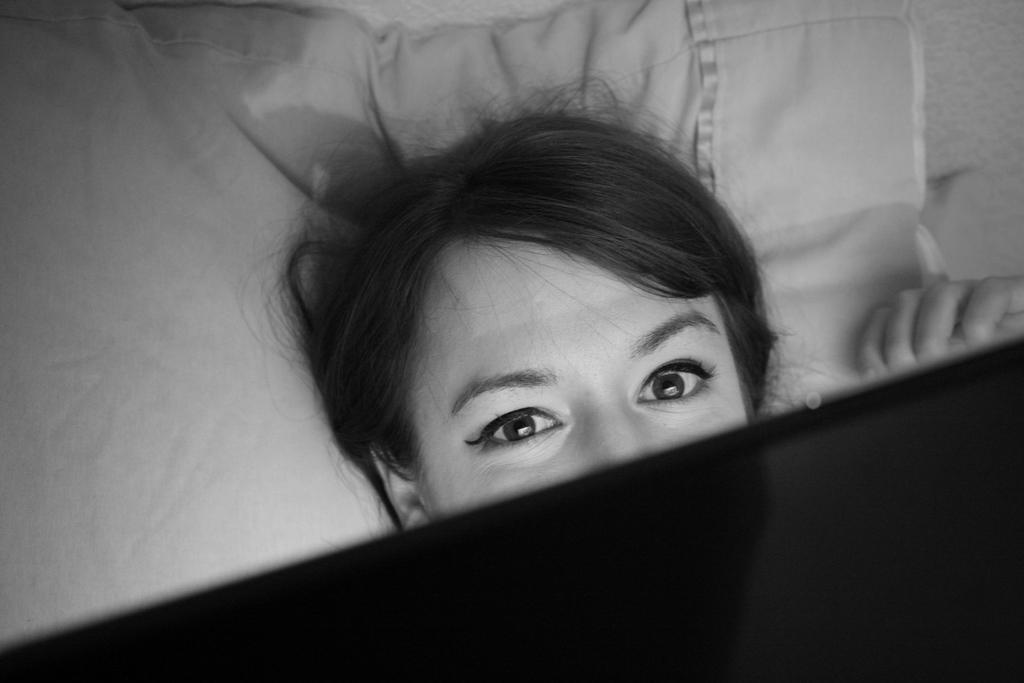Who is present in the image? There is a woman in the image. What part of the woman's face is visible? The woman's eyes are visible in the image. What is the woman doing in the image? The woman is lying on a bed. What type of sock is the woman wearing on her left foot in the image? There is no sock visible on the woman's left foot in the image, as she is lying on a bed and her feet are not shown. 